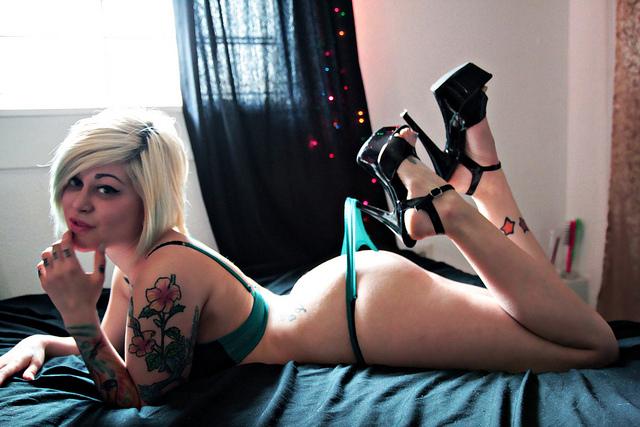Where is the star tattoo?
Keep it brief. Lower leg near ankle. Would most people consider her pose sexually suggestive?
Keep it brief. Yes. Is she wearing flat heels?
Short answer required. No. Is she laying on her belly?
Short answer required. Yes. What is the black object on the blanket?
Keep it brief. Shoes. 